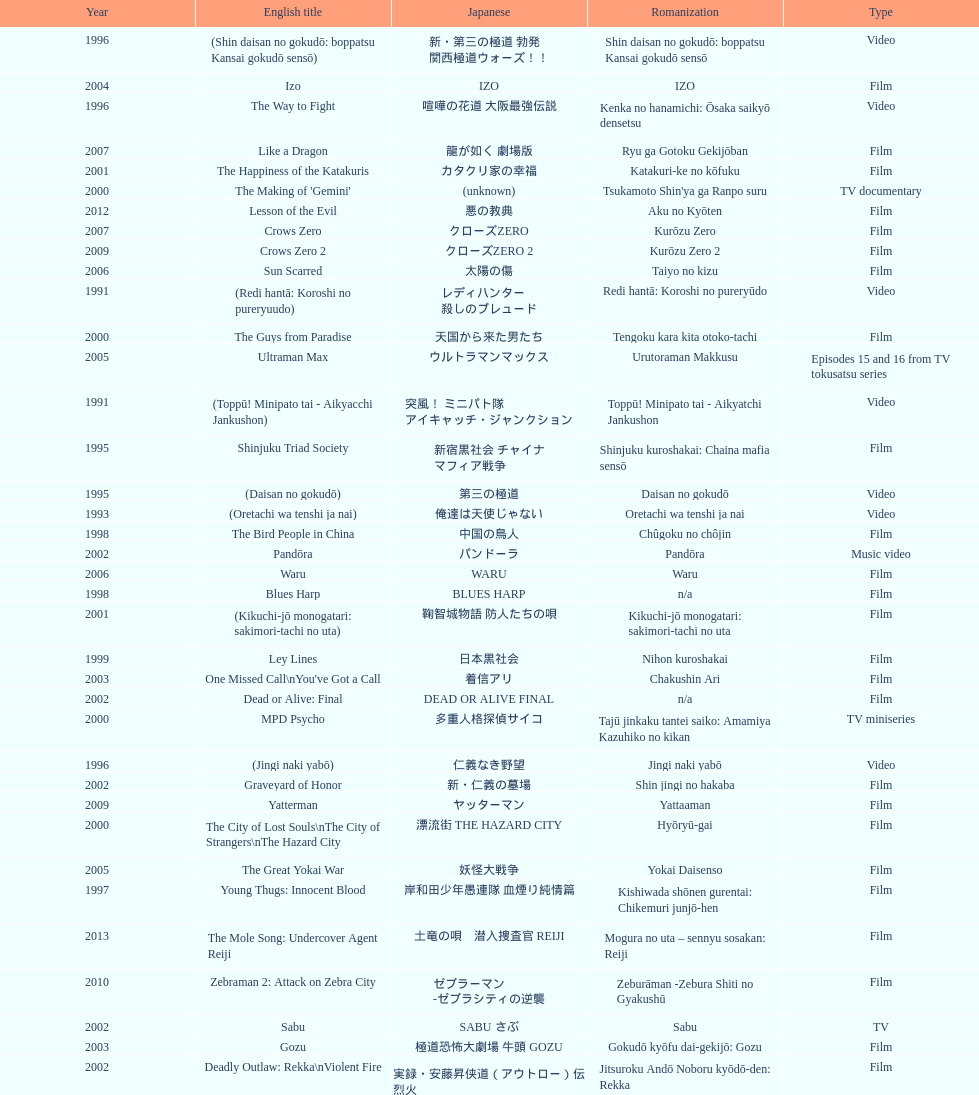Were more air on tv or video? Video. 